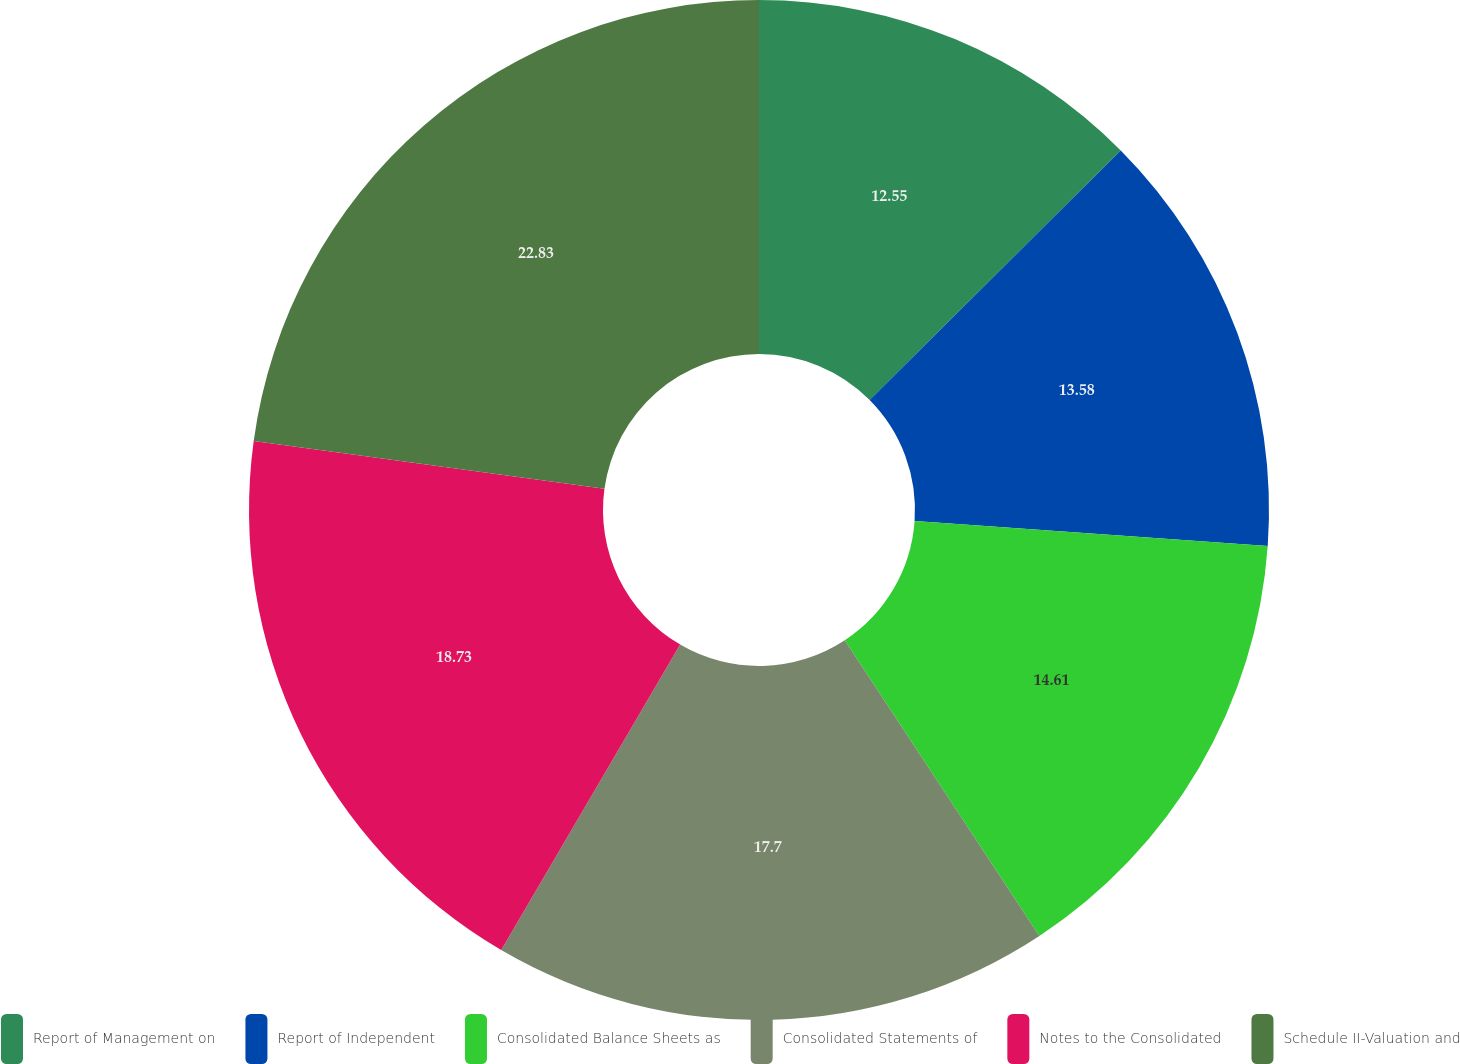Convert chart. <chart><loc_0><loc_0><loc_500><loc_500><pie_chart><fcel>Report of Management on<fcel>Report of Independent<fcel>Consolidated Balance Sheets as<fcel>Consolidated Statements of<fcel>Notes to the Consolidated<fcel>Schedule II-Valuation and<nl><fcel>12.55%<fcel>13.58%<fcel>14.61%<fcel>17.7%<fcel>18.73%<fcel>22.84%<nl></chart> 